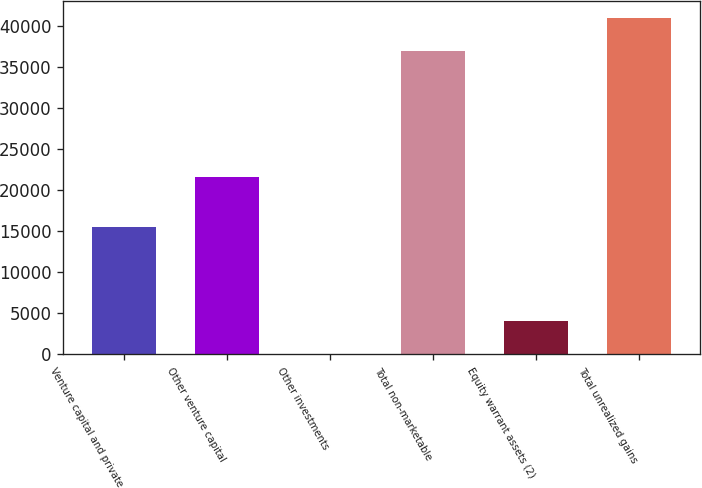Convert chart. <chart><loc_0><loc_0><loc_500><loc_500><bar_chart><fcel>Venture capital and private<fcel>Other venture capital<fcel>Other investments<fcel>Total non-marketable<fcel>Equity warrant assets (2)<fcel>Total unrealized gains<nl><fcel>15460<fcel>21526<fcel>18<fcel>36968<fcel>4039.8<fcel>40989.8<nl></chart> 